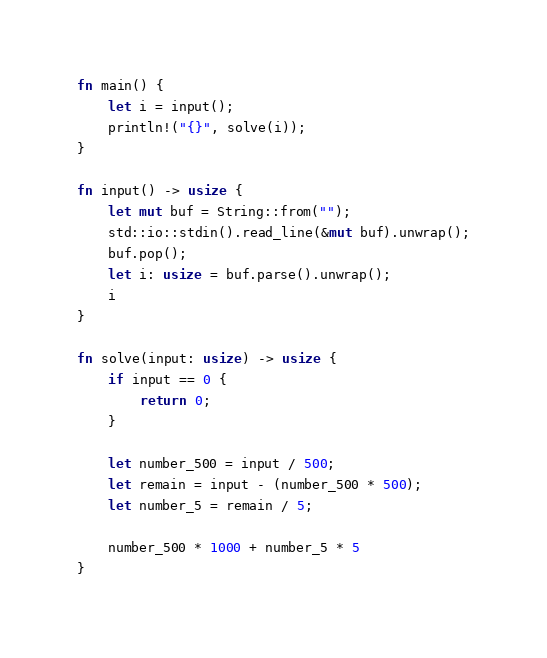Convert code to text. <code><loc_0><loc_0><loc_500><loc_500><_Rust_>fn main() {
    let i = input();
    println!("{}", solve(i));
}

fn input() -> usize {
    let mut buf = String::from("");
    std::io::stdin().read_line(&mut buf).unwrap();
    buf.pop();
    let i: usize = buf.parse().unwrap();
    i
}

fn solve(input: usize) -> usize {
    if input == 0 {
        return 0;
    }

    let number_500 = input / 500;
    let remain = input - (number_500 * 500);
    let number_5 = remain / 5;

    number_500 * 1000 + number_5 * 5
}</code> 